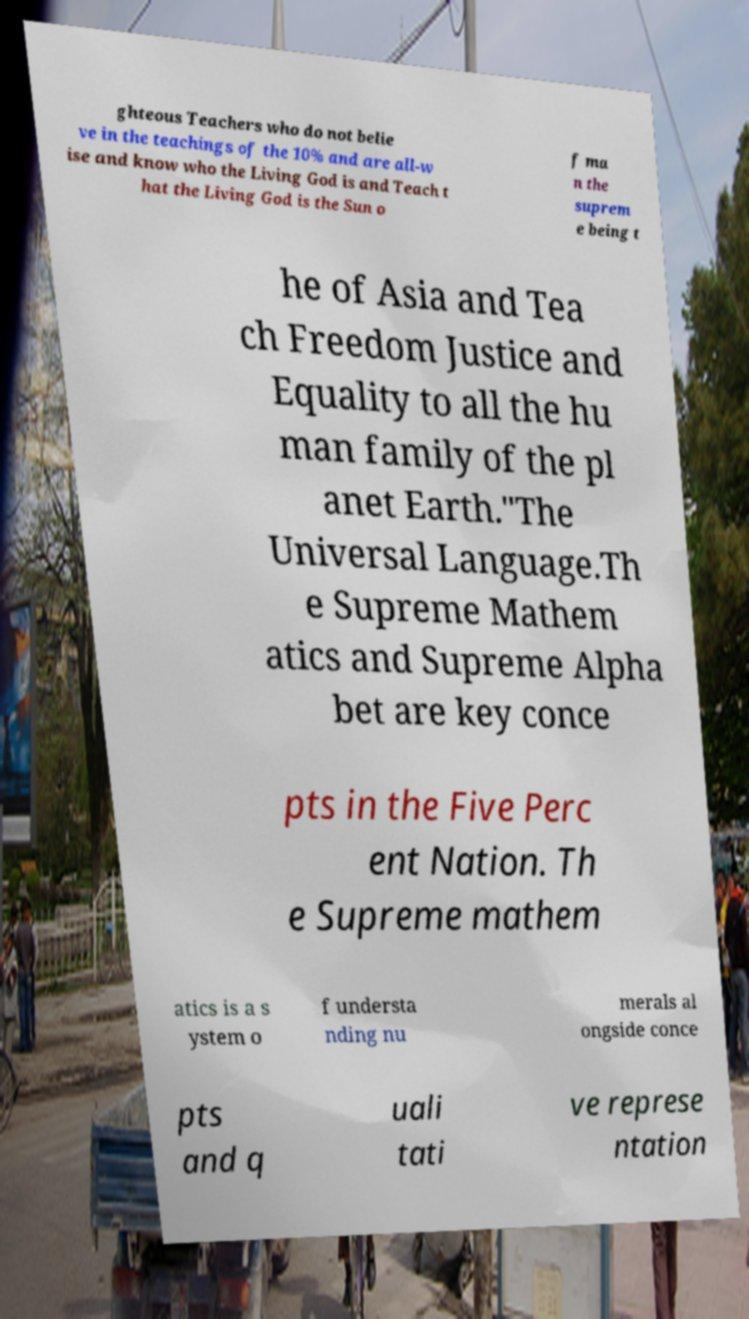Could you assist in decoding the text presented in this image and type it out clearly? ghteous Teachers who do not belie ve in the teachings of the 10% and are all-w ise and know who the Living God is and Teach t hat the Living God is the Sun o f ma n the suprem e being t he of Asia and Tea ch Freedom Justice and Equality to all the hu man family of the pl anet Earth."The Universal Language.Th e Supreme Mathem atics and Supreme Alpha bet are key conce pts in the Five Perc ent Nation. Th e Supreme mathem atics is a s ystem o f understa nding nu merals al ongside conce pts and q uali tati ve represe ntation 